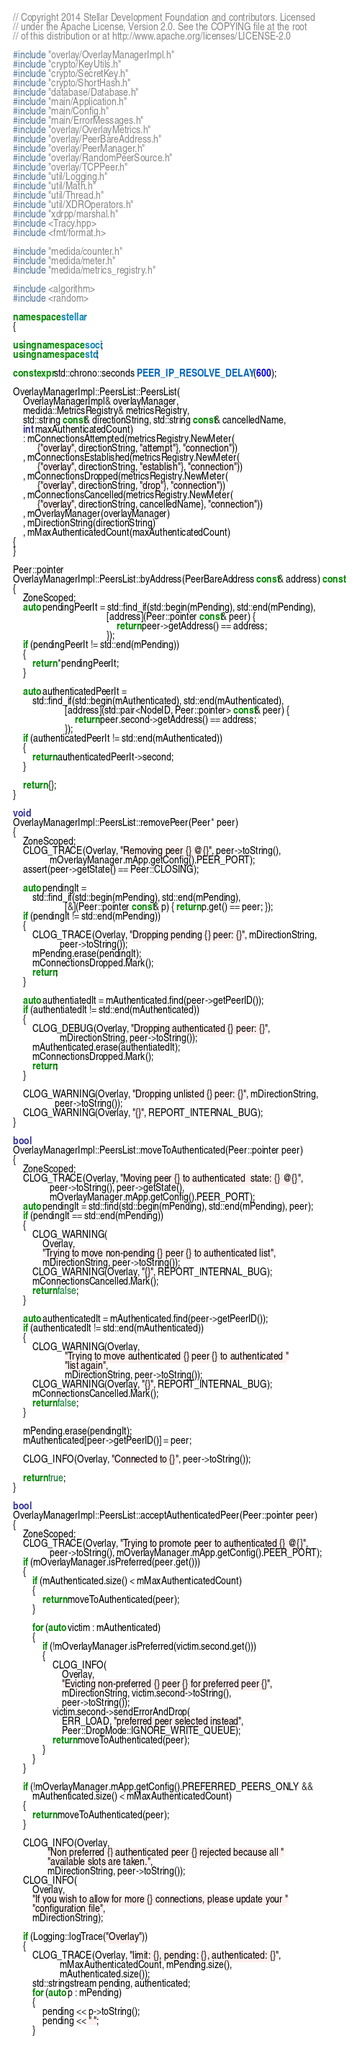Convert code to text. <code><loc_0><loc_0><loc_500><loc_500><_C++_>// Copyright 2014 Stellar Development Foundation and contributors. Licensed
// under the Apache License, Version 2.0. See the COPYING file at the root
// of this distribution or at http://www.apache.org/licenses/LICENSE-2.0

#include "overlay/OverlayManagerImpl.h"
#include "crypto/KeyUtils.h"
#include "crypto/SecretKey.h"
#include "crypto/ShortHash.h"
#include "database/Database.h"
#include "main/Application.h"
#include "main/Config.h"
#include "main/ErrorMessages.h"
#include "overlay/OverlayMetrics.h"
#include "overlay/PeerBareAddress.h"
#include "overlay/PeerManager.h"
#include "overlay/RandomPeerSource.h"
#include "overlay/TCPPeer.h"
#include "util/Logging.h"
#include "util/Math.h"
#include "util/Thread.h"
#include "util/XDROperators.h"
#include "xdrpp/marshal.h"
#include <Tracy.hpp>
#include <fmt/format.h>

#include "medida/counter.h"
#include "medida/meter.h"
#include "medida/metrics_registry.h"

#include <algorithm>
#include <random>

namespace stellar
{

using namespace soci;
using namespace std;

constexpr std::chrono::seconds PEER_IP_RESOLVE_DELAY(600);

OverlayManagerImpl::PeersList::PeersList(
    OverlayManagerImpl& overlayManager,
    medida::MetricsRegistry& metricsRegistry,
    std::string const& directionString, std::string const& cancelledName,
    int maxAuthenticatedCount)
    : mConnectionsAttempted(metricsRegistry.NewMeter(
          {"overlay", directionString, "attempt"}, "connection"))
    , mConnectionsEstablished(metricsRegistry.NewMeter(
          {"overlay", directionString, "establish"}, "connection"))
    , mConnectionsDropped(metricsRegistry.NewMeter(
          {"overlay", directionString, "drop"}, "connection"))
    , mConnectionsCancelled(metricsRegistry.NewMeter(
          {"overlay", directionString, cancelledName}, "connection"))
    , mOverlayManager(overlayManager)
    , mDirectionString(directionString)
    , mMaxAuthenticatedCount(maxAuthenticatedCount)
{
}

Peer::pointer
OverlayManagerImpl::PeersList::byAddress(PeerBareAddress const& address) const
{
    ZoneScoped;
    auto pendingPeerIt = std::find_if(std::begin(mPending), std::end(mPending),
                                      [address](Peer::pointer const& peer) {
                                          return peer->getAddress() == address;
                                      });
    if (pendingPeerIt != std::end(mPending))
    {
        return *pendingPeerIt;
    }

    auto authenticatedPeerIt =
        std::find_if(std::begin(mAuthenticated), std::end(mAuthenticated),
                     [address](std::pair<NodeID, Peer::pointer> const& peer) {
                         return peer.second->getAddress() == address;
                     });
    if (authenticatedPeerIt != std::end(mAuthenticated))
    {
        return authenticatedPeerIt->second;
    }

    return {};
}

void
OverlayManagerImpl::PeersList::removePeer(Peer* peer)
{
    ZoneScoped;
    CLOG_TRACE(Overlay, "Removing peer {} @{}", peer->toString(),
               mOverlayManager.mApp.getConfig().PEER_PORT);
    assert(peer->getState() == Peer::CLOSING);

    auto pendingIt =
        std::find_if(std::begin(mPending), std::end(mPending),
                     [&](Peer::pointer const& p) { return p.get() == peer; });
    if (pendingIt != std::end(mPending))
    {
        CLOG_TRACE(Overlay, "Dropping pending {} peer: {}", mDirectionString,
                   peer->toString());
        mPending.erase(pendingIt);
        mConnectionsDropped.Mark();
        return;
    }

    auto authentiatedIt = mAuthenticated.find(peer->getPeerID());
    if (authentiatedIt != std::end(mAuthenticated))
    {
        CLOG_DEBUG(Overlay, "Dropping authenticated {} peer: {}",
                   mDirectionString, peer->toString());
        mAuthenticated.erase(authentiatedIt);
        mConnectionsDropped.Mark();
        return;
    }

    CLOG_WARNING(Overlay, "Dropping unlisted {} peer: {}", mDirectionString,
                 peer->toString());
    CLOG_WARNING(Overlay, "{}", REPORT_INTERNAL_BUG);
}

bool
OverlayManagerImpl::PeersList::moveToAuthenticated(Peer::pointer peer)
{
    ZoneScoped;
    CLOG_TRACE(Overlay, "Moving peer {} to authenticated  state: {} @{}",
               peer->toString(), peer->getState(),
               mOverlayManager.mApp.getConfig().PEER_PORT);
    auto pendingIt = std::find(std::begin(mPending), std::end(mPending), peer);
    if (pendingIt == std::end(mPending))
    {
        CLOG_WARNING(
            Overlay,
            "Trying to move non-pending {} peer {} to authenticated list",
            mDirectionString, peer->toString());
        CLOG_WARNING(Overlay, "{}", REPORT_INTERNAL_BUG);
        mConnectionsCancelled.Mark();
        return false;
    }

    auto authenticatedIt = mAuthenticated.find(peer->getPeerID());
    if (authenticatedIt != std::end(mAuthenticated))
    {
        CLOG_WARNING(Overlay,
                     "Trying to move authenticated {} peer {} to authenticated "
                     "list again",
                     mDirectionString, peer->toString());
        CLOG_WARNING(Overlay, "{}", REPORT_INTERNAL_BUG);
        mConnectionsCancelled.Mark();
        return false;
    }

    mPending.erase(pendingIt);
    mAuthenticated[peer->getPeerID()] = peer;

    CLOG_INFO(Overlay, "Connected to {}", peer->toString());

    return true;
}

bool
OverlayManagerImpl::PeersList::acceptAuthenticatedPeer(Peer::pointer peer)
{
    ZoneScoped;
    CLOG_TRACE(Overlay, "Trying to promote peer to authenticated {} @{}",
               peer->toString(), mOverlayManager.mApp.getConfig().PEER_PORT);
    if (mOverlayManager.isPreferred(peer.get()))
    {
        if (mAuthenticated.size() < mMaxAuthenticatedCount)
        {
            return moveToAuthenticated(peer);
        }

        for (auto victim : mAuthenticated)
        {
            if (!mOverlayManager.isPreferred(victim.second.get()))
            {
                CLOG_INFO(
                    Overlay,
                    "Evicting non-preferred {} peer {} for preferred peer {}",
                    mDirectionString, victim.second->toString(),
                    peer->toString());
                victim.second->sendErrorAndDrop(
                    ERR_LOAD, "preferred peer selected instead",
                    Peer::DropMode::IGNORE_WRITE_QUEUE);
                return moveToAuthenticated(peer);
            }
        }
    }

    if (!mOverlayManager.mApp.getConfig().PREFERRED_PEERS_ONLY &&
        mAuthenticated.size() < mMaxAuthenticatedCount)
    {
        return moveToAuthenticated(peer);
    }

    CLOG_INFO(Overlay,
              "Non preferred {} authenticated peer {} rejected because all "
              "available slots are taken.",
              mDirectionString, peer->toString());
    CLOG_INFO(
        Overlay,
        "If you wish to allow for more {} connections, please update your "
        "configuration file",
        mDirectionString);

    if (Logging::logTrace("Overlay"))
    {
        CLOG_TRACE(Overlay, "limit: {}, pending: {}, authenticated: {}",
                   mMaxAuthenticatedCount, mPending.size(),
                   mAuthenticated.size());
        std::stringstream pending, authenticated;
        for (auto p : mPending)
        {
            pending << p->toString();
            pending << " ";
        }</code> 